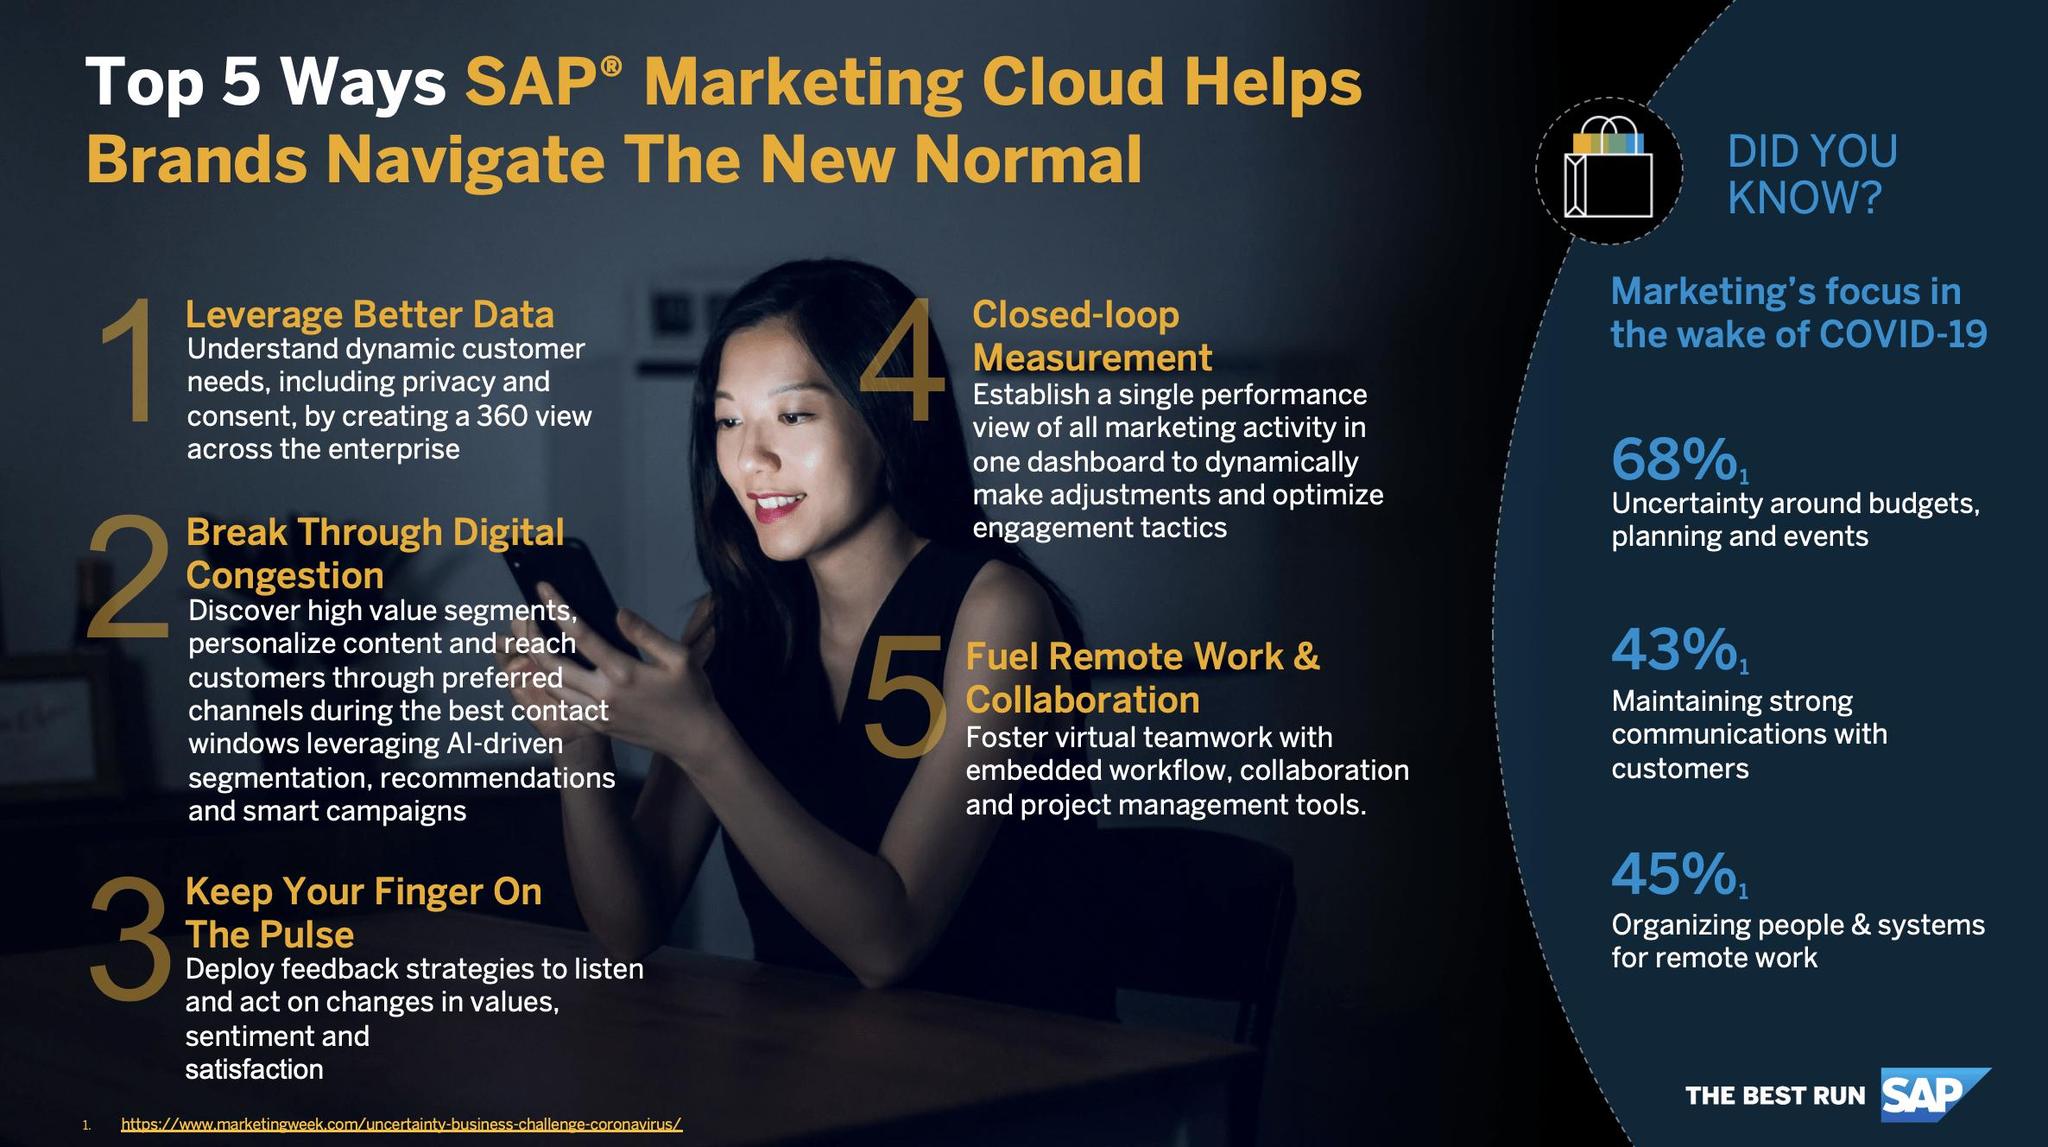List a handful of essential elements in this visual. SAP has successfully resolved 43% of issues related to maintaining a line with customer interests. 